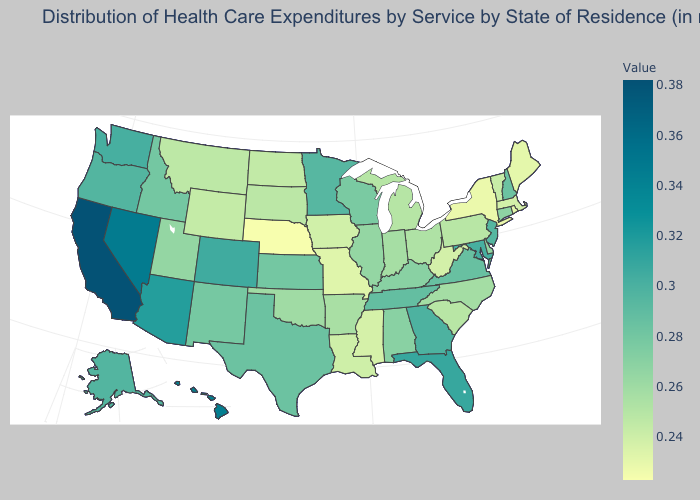Does the map have missing data?
Be succinct. No. Does Arkansas have a higher value than New Jersey?
Write a very short answer. No. Which states have the lowest value in the USA?
Concise answer only. Nebraska. Does Massachusetts have the highest value in the Northeast?
Write a very short answer. No. 